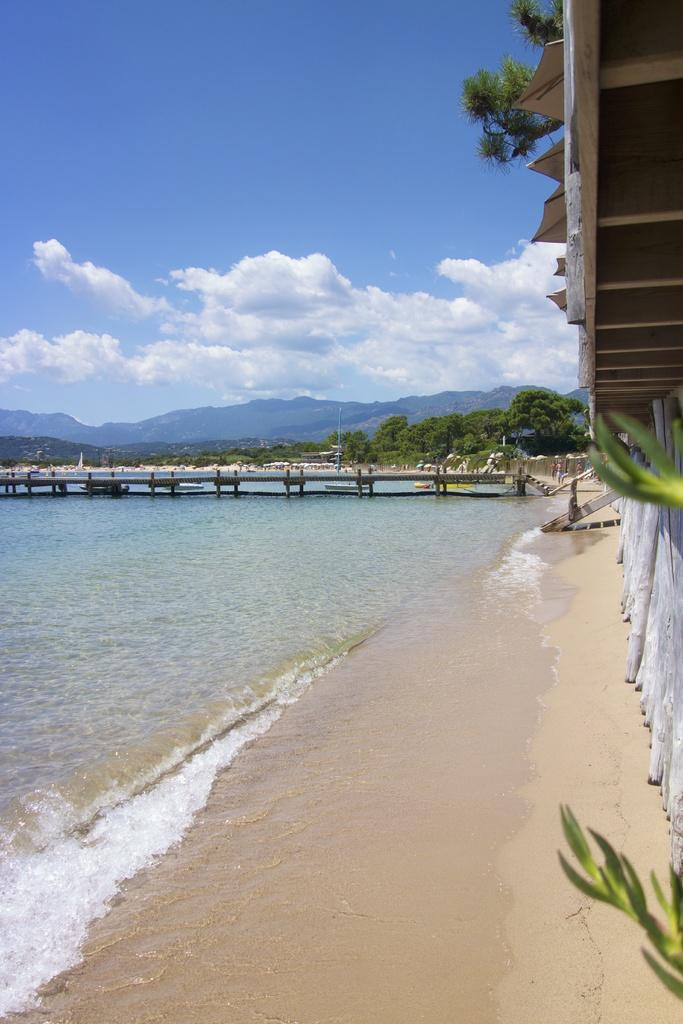What type of terrain is visible in the image? There is sand in the image. What type of structure can be seen in the image? There is a building in the image. What type of plant is present in the image? There is a tree in the image. What natural feature is visible in the image? There is water visible in the image. What type of man-made structure can be seen in the background? In the background, there is a bridge. What other structures can be seen in the background? There are additional buildings in the background. What type of vegetation is present in the background? There are trees in the background in the background. What type of geological feature is present in the background? There are mountains in the background. What part of the natural environment is visible in the background? The sky is visible in the background. What type of hole can be seen in the image? There is no hole present in the image. What type of writing can be seen on the tree in the image? There is no writing visible on the tree in the image. 